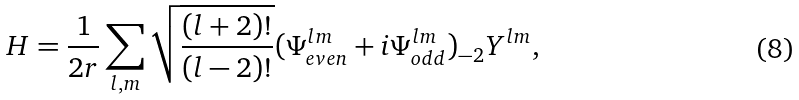Convert formula to latex. <formula><loc_0><loc_0><loc_500><loc_500>H = \frac { 1 } { 2 r } \sum _ { l , m } \sqrt { \frac { ( l + 2 ) ! } { ( l - 2 ) ! } } ( \Psi ^ { l m } _ { e v e n } + i \Psi ^ { l m } _ { o d d } ) _ { - 2 } Y ^ { l m } ,</formula> 